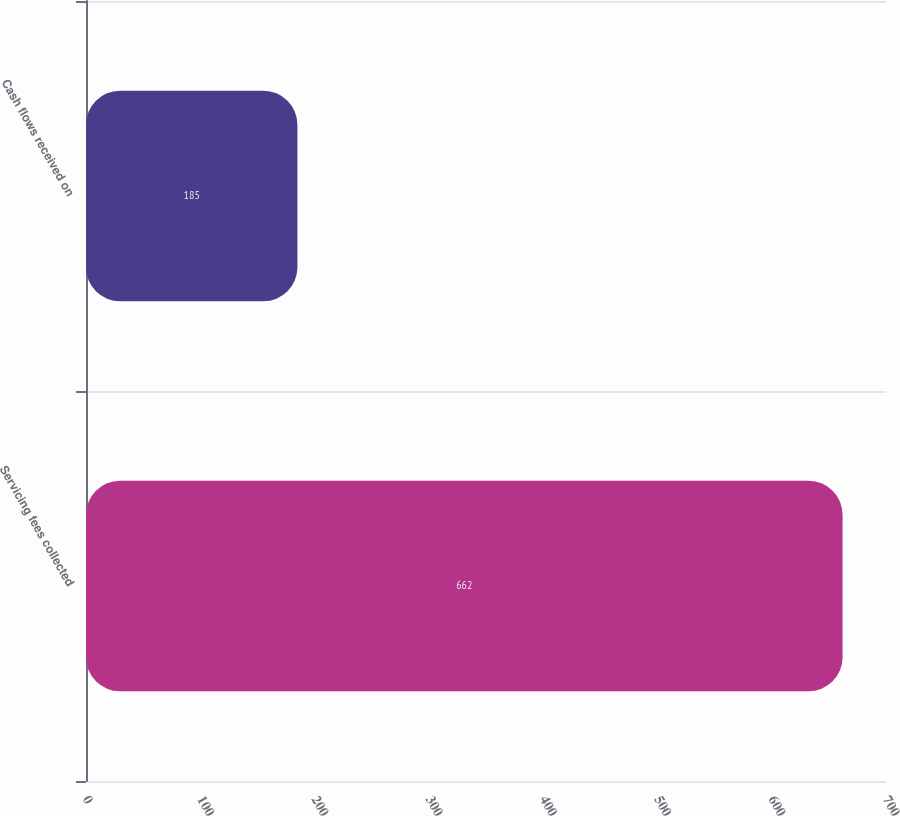Convert chart. <chart><loc_0><loc_0><loc_500><loc_500><bar_chart><fcel>Servicing fees collected<fcel>Cash flows received on<nl><fcel>662<fcel>185<nl></chart> 